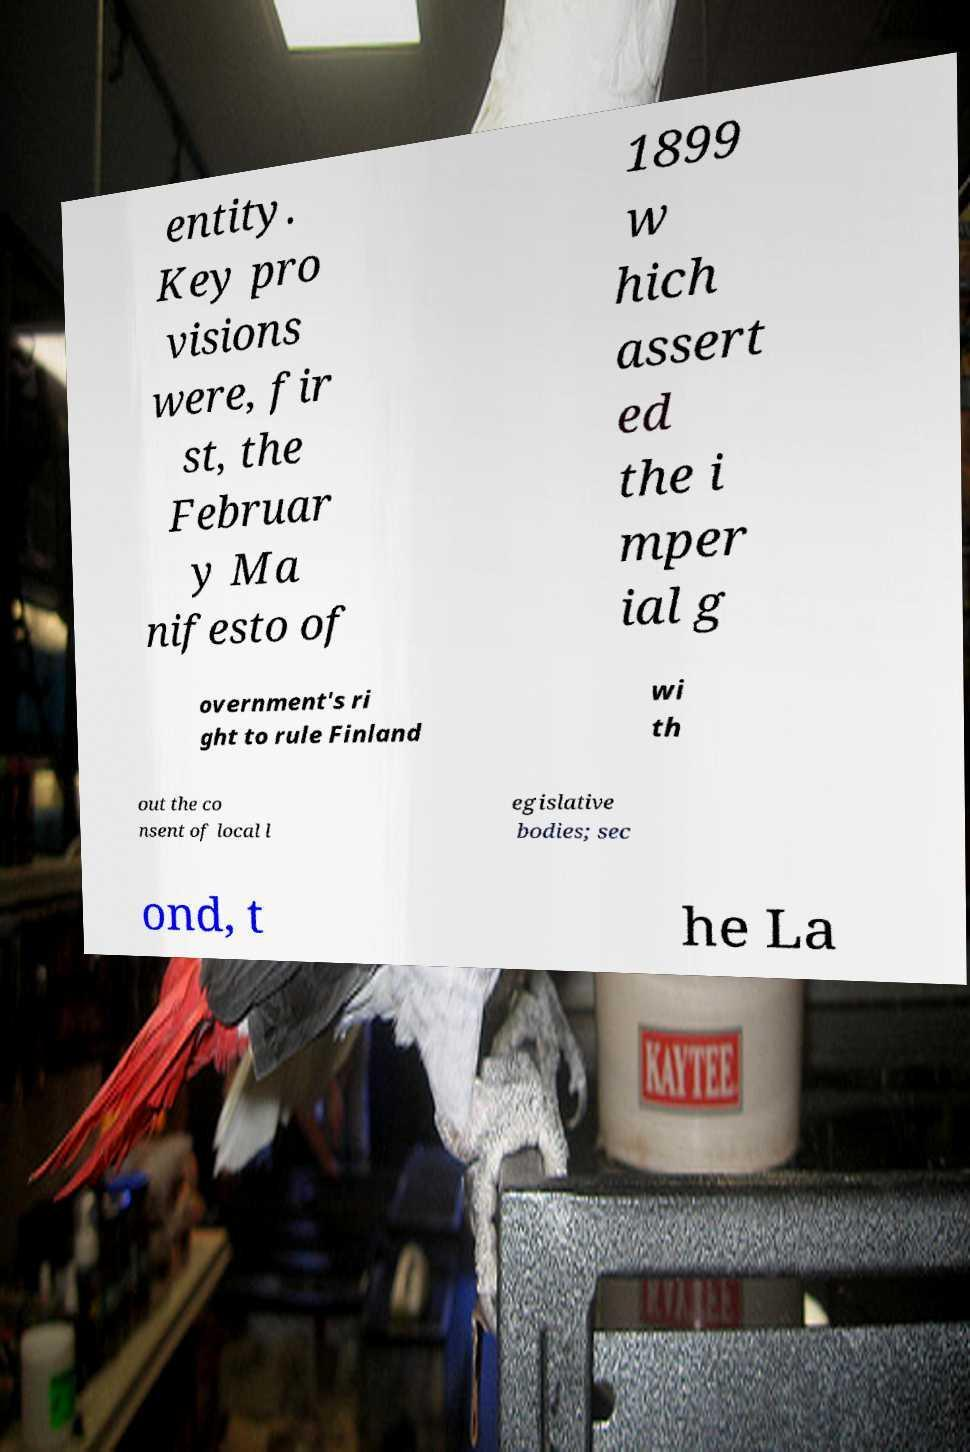Can you read and provide the text displayed in the image?This photo seems to have some interesting text. Can you extract and type it out for me? entity. Key pro visions were, fir st, the Februar y Ma nifesto of 1899 w hich assert ed the i mper ial g overnment's ri ght to rule Finland wi th out the co nsent of local l egislative bodies; sec ond, t he La 